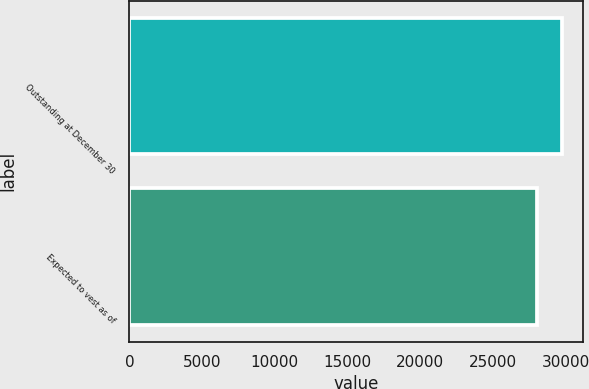Convert chart to OTSL. <chart><loc_0><loc_0><loc_500><loc_500><bar_chart><fcel>Outstanding at December 30<fcel>Expected to vest as of<nl><fcel>29734<fcel>28034<nl></chart> 